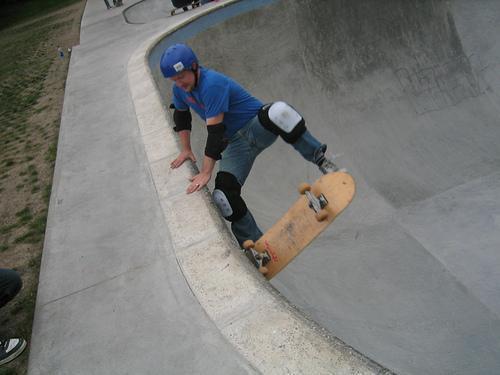How many people are there?
Give a very brief answer. 1. 